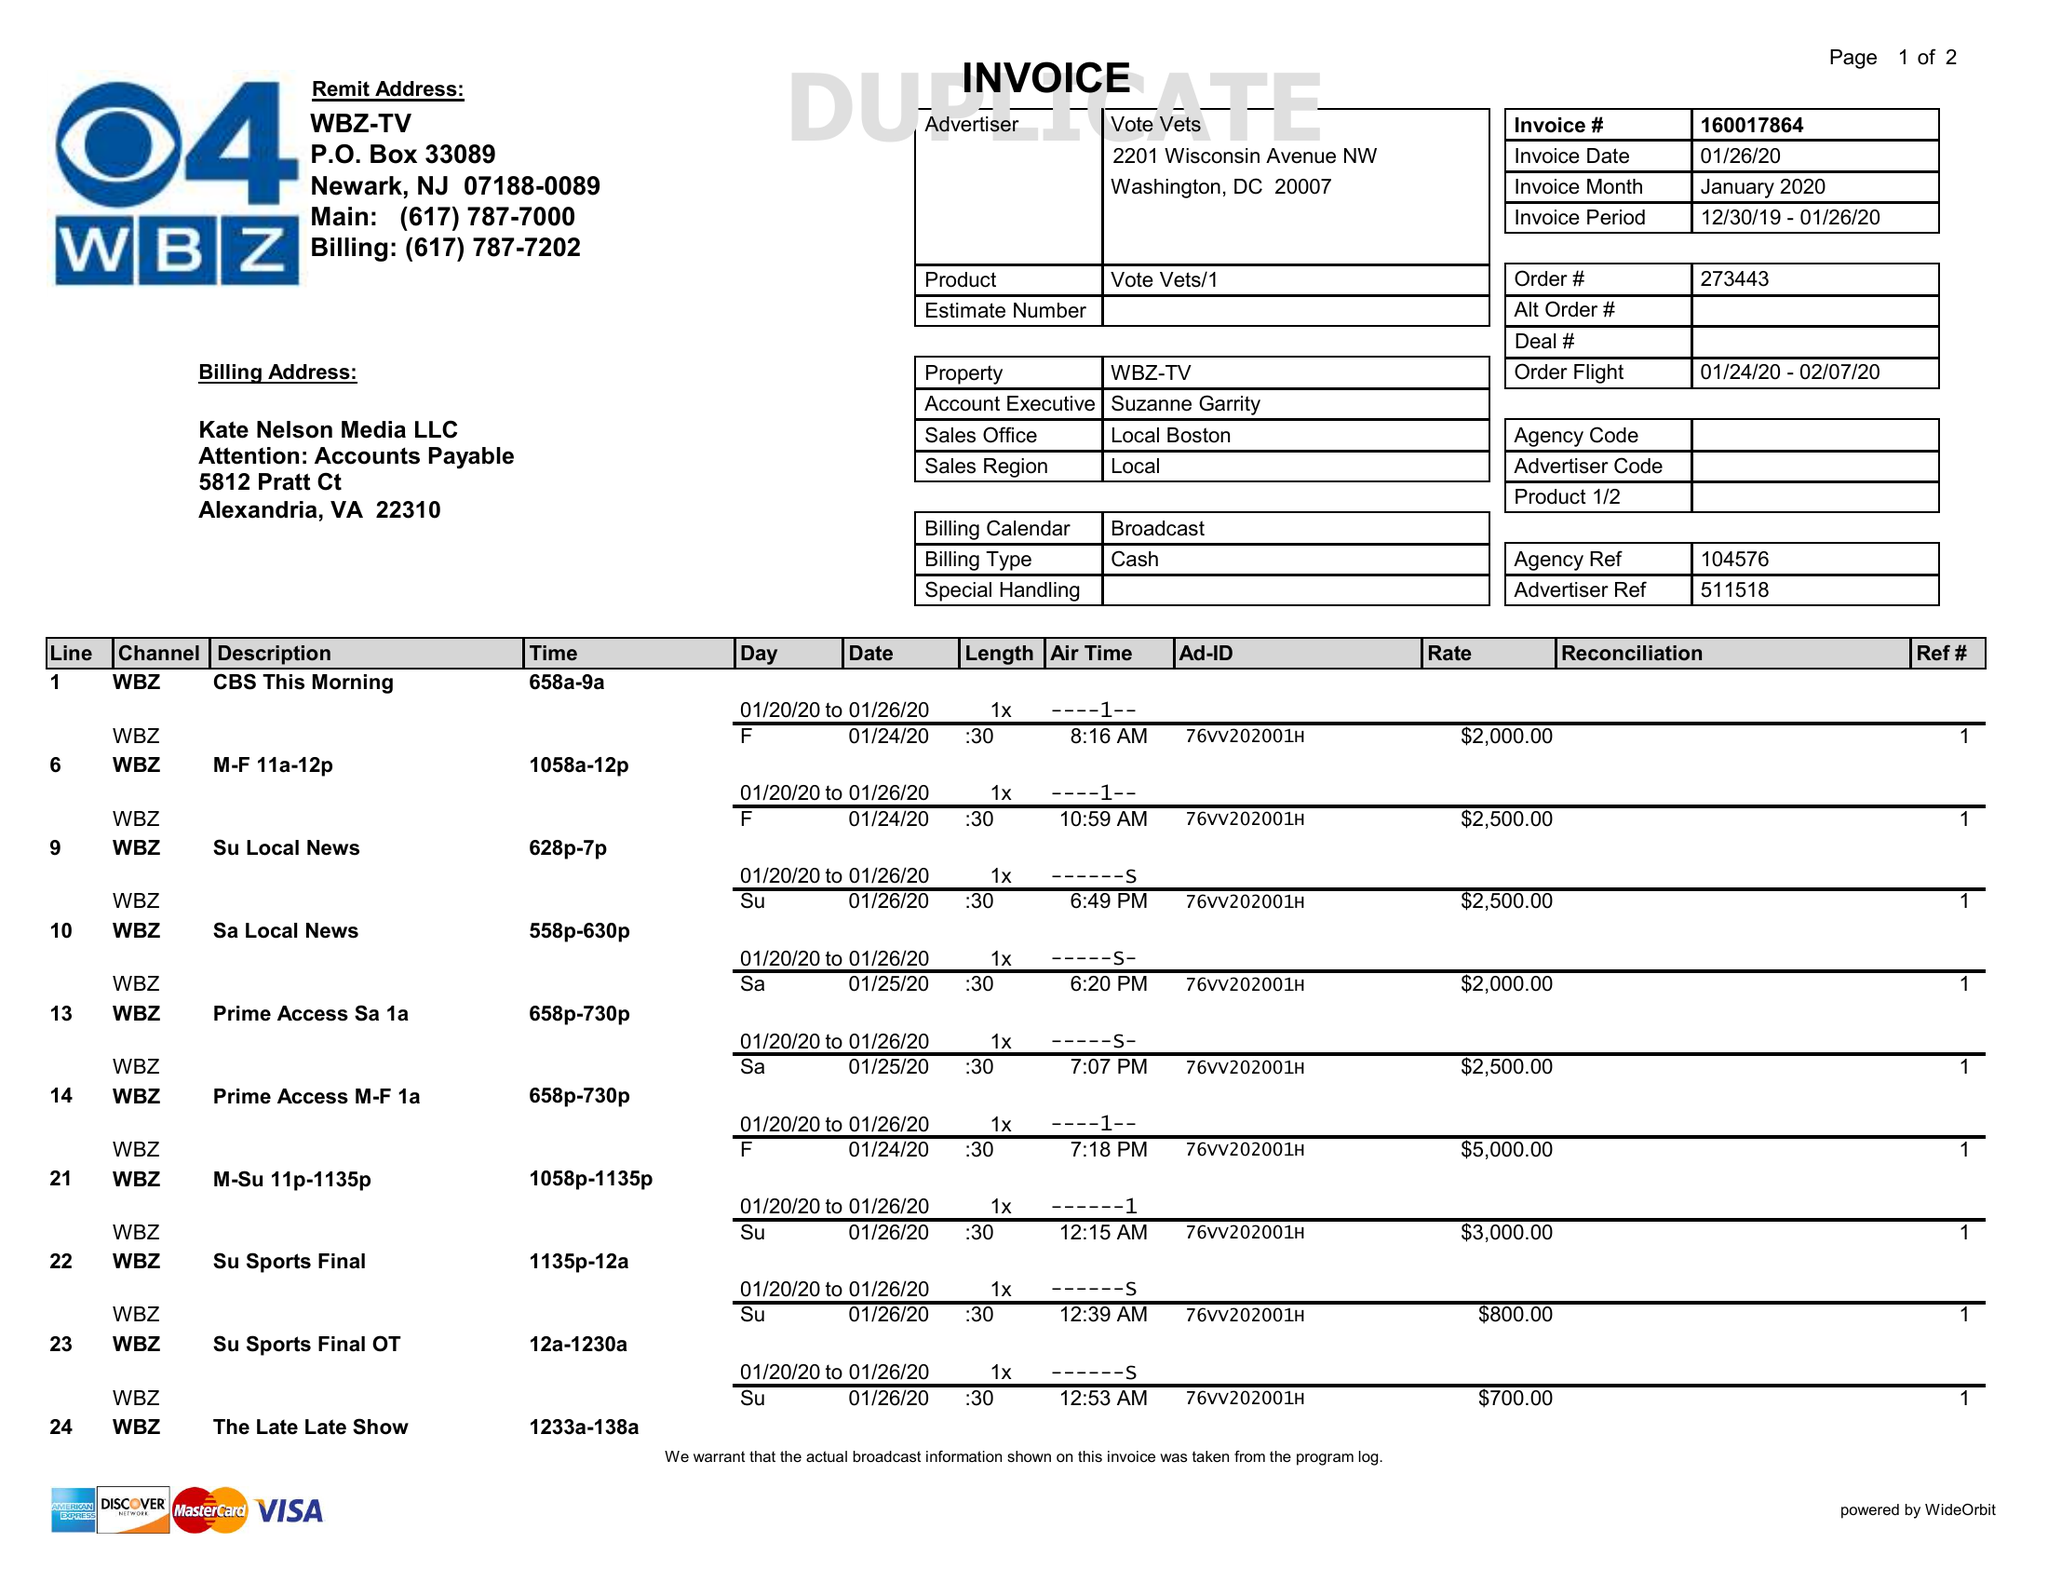What is the value for the advertiser?
Answer the question using a single word or phrase. VOTE VETS 